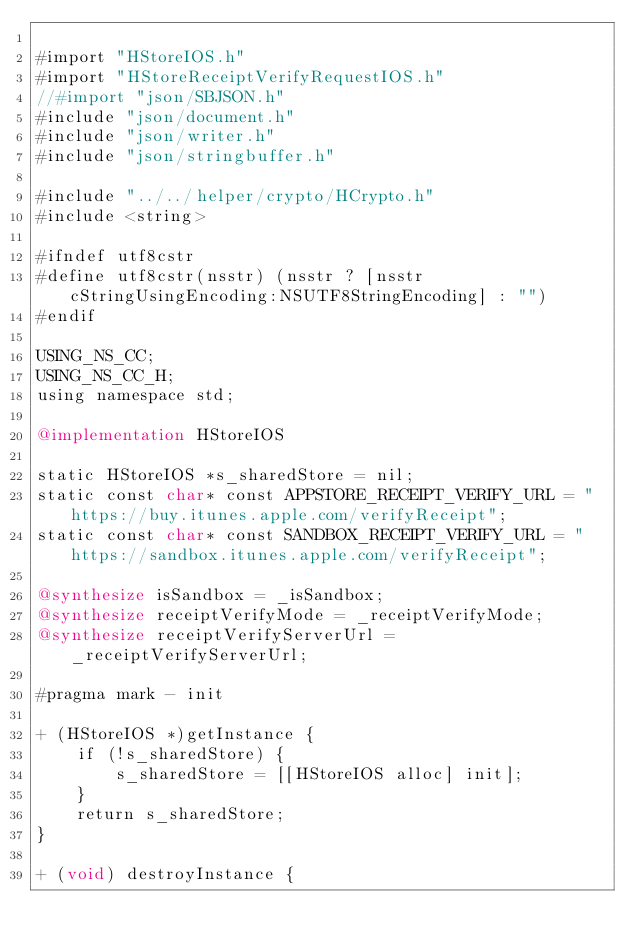<code> <loc_0><loc_0><loc_500><loc_500><_ObjectiveC_>
#import "HStoreIOS.h"
#import "HStoreReceiptVerifyRequestIOS.h"
//#import "json/SBJSON.h"
#include "json/document.h"
#include "json/writer.h"
#include "json/stringbuffer.h"

#include "../../helper/crypto/HCrypto.h"
#include <string>

#ifndef utf8cstr
#define utf8cstr(nsstr) (nsstr ? [nsstr cStringUsingEncoding:NSUTF8StringEncoding] : "")
#endif

USING_NS_CC;
USING_NS_CC_H;
using namespace std;

@implementation HStoreIOS

static HStoreIOS *s_sharedStore = nil;
static const char* const APPSTORE_RECEIPT_VERIFY_URL = "https://buy.itunes.apple.com/verifyReceipt";
static const char* const SANDBOX_RECEIPT_VERIFY_URL = "https://sandbox.itunes.apple.com/verifyReceipt";

@synthesize isSandbox = _isSandbox;
@synthesize receiptVerifyMode = _receiptVerifyMode;
@synthesize receiptVerifyServerUrl = _receiptVerifyServerUrl;

#pragma mark - init

+ (HStoreIOS *)getInstance {
    if (!s_sharedStore) {
        s_sharedStore = [[HStoreIOS alloc] init];
    }
    return s_sharedStore;
}

+ (void) destroyInstance {</code> 